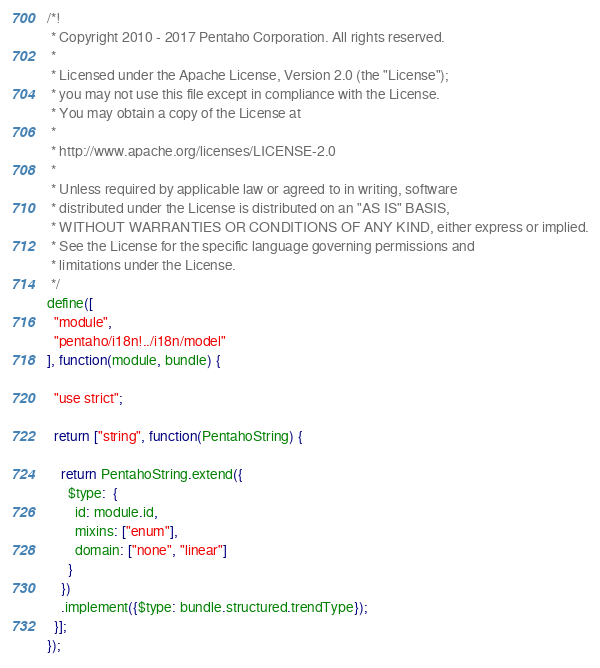Convert code to text. <code><loc_0><loc_0><loc_500><loc_500><_JavaScript_>/*!
 * Copyright 2010 - 2017 Pentaho Corporation. All rights reserved.
 *
 * Licensed under the Apache License, Version 2.0 (the "License");
 * you may not use this file except in compliance with the License.
 * You may obtain a copy of the License at
 *
 * http://www.apache.org/licenses/LICENSE-2.0
 *
 * Unless required by applicable law or agreed to in writing, software
 * distributed under the License is distributed on an "AS IS" BASIS,
 * WITHOUT WARRANTIES OR CONDITIONS OF ANY KIND, either express or implied.
 * See the License for the specific language governing permissions and
 * limitations under the License.
 */
define([
  "module",
  "pentaho/i18n!../i18n/model"
], function(module, bundle) {

  "use strict";

  return ["string", function(PentahoString) {

    return PentahoString.extend({
      $type:  {
        id: module.id,
        mixins: ["enum"],
        domain: ["none", "linear"]
      }
    })
    .implement({$type: bundle.structured.trendType});
  }];
});
</code> 